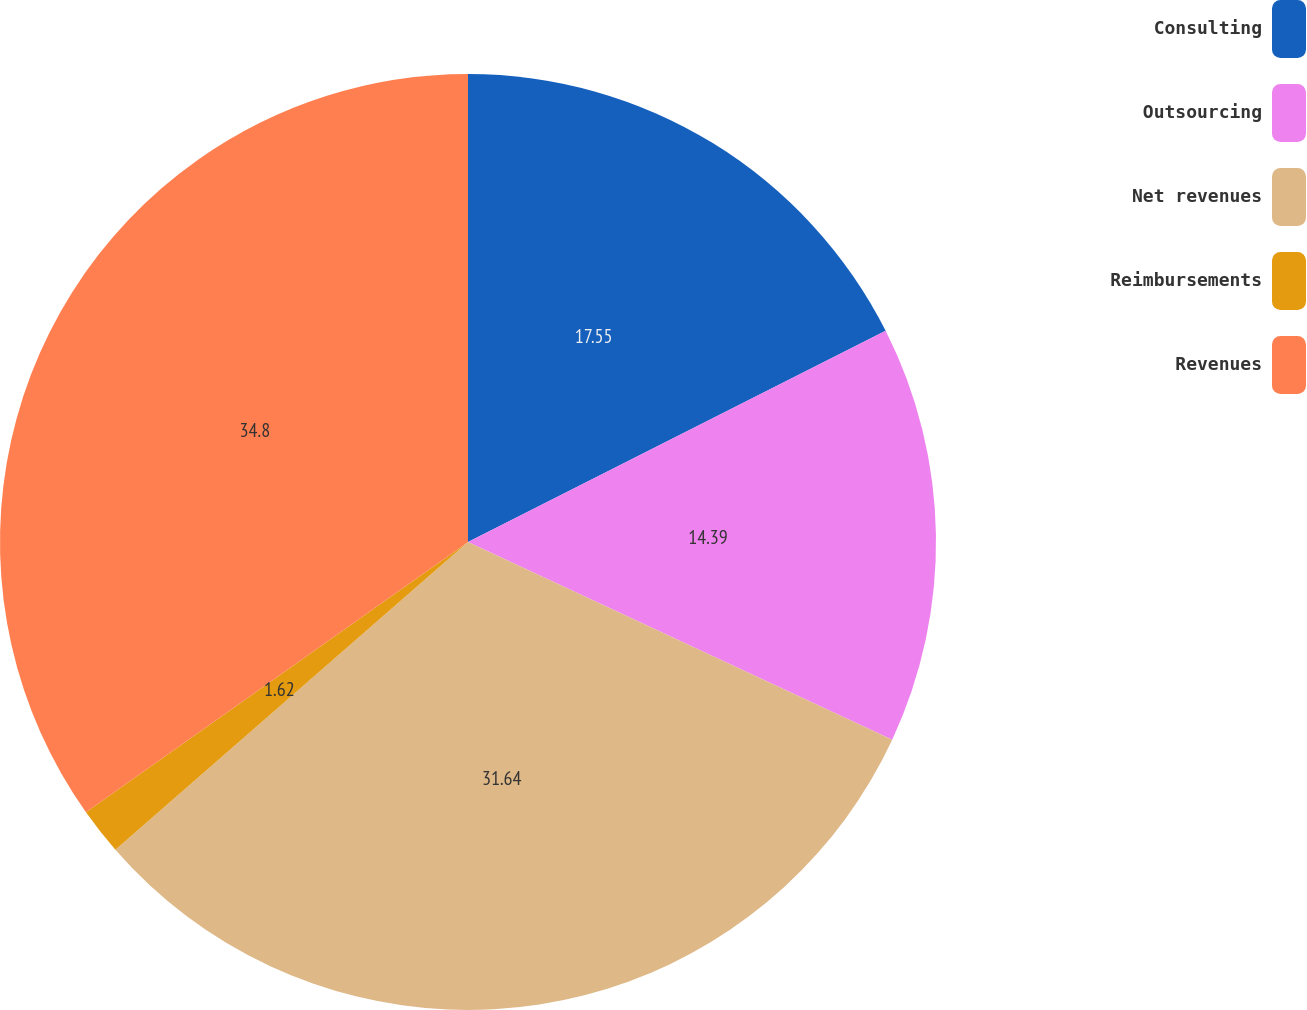<chart> <loc_0><loc_0><loc_500><loc_500><pie_chart><fcel>Consulting<fcel>Outsourcing<fcel>Net revenues<fcel>Reimbursements<fcel>Revenues<nl><fcel>17.55%<fcel>14.39%<fcel>31.64%<fcel>1.62%<fcel>34.8%<nl></chart> 